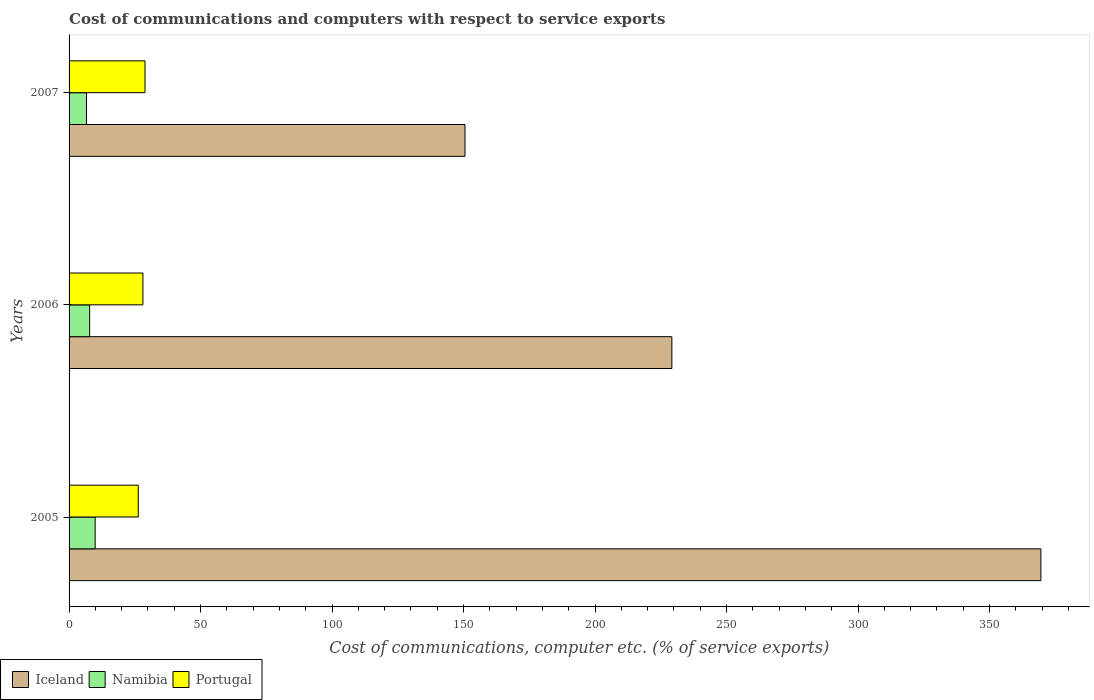How many different coloured bars are there?
Your answer should be very brief. 3. Are the number of bars per tick equal to the number of legend labels?
Ensure brevity in your answer.  Yes. How many bars are there on the 2nd tick from the bottom?
Ensure brevity in your answer.  3. In how many cases, is the number of bars for a given year not equal to the number of legend labels?
Provide a succinct answer. 0. What is the cost of communications and computers in Namibia in 2005?
Give a very brief answer. 9.92. Across all years, what is the maximum cost of communications and computers in Portugal?
Give a very brief answer. 28.88. Across all years, what is the minimum cost of communications and computers in Namibia?
Provide a short and direct response. 6.63. In which year was the cost of communications and computers in Iceland minimum?
Your answer should be very brief. 2007. What is the total cost of communications and computers in Namibia in the graph?
Provide a succinct answer. 24.37. What is the difference between the cost of communications and computers in Iceland in 2006 and that in 2007?
Offer a very short reply. 78.66. What is the difference between the cost of communications and computers in Namibia in 2005 and the cost of communications and computers in Portugal in 2007?
Ensure brevity in your answer.  -18.95. What is the average cost of communications and computers in Portugal per year?
Offer a terse response. 27.76. In the year 2005, what is the difference between the cost of communications and computers in Namibia and cost of communications and computers in Iceland?
Ensure brevity in your answer.  -359.62. In how many years, is the cost of communications and computers in Portugal greater than 300 %?
Give a very brief answer. 0. What is the ratio of the cost of communications and computers in Portugal in 2005 to that in 2007?
Offer a very short reply. 0.91. Is the difference between the cost of communications and computers in Namibia in 2005 and 2006 greater than the difference between the cost of communications and computers in Iceland in 2005 and 2006?
Give a very brief answer. No. What is the difference between the highest and the second highest cost of communications and computers in Iceland?
Make the answer very short. 140.33. What is the difference between the highest and the lowest cost of communications and computers in Portugal?
Your answer should be very brief. 2.57. Is the sum of the cost of communications and computers in Portugal in 2005 and 2007 greater than the maximum cost of communications and computers in Namibia across all years?
Your answer should be very brief. Yes. What does the 3rd bar from the top in 2007 represents?
Keep it short and to the point. Iceland. What does the 2nd bar from the bottom in 2006 represents?
Provide a succinct answer. Namibia. Is it the case that in every year, the sum of the cost of communications and computers in Iceland and cost of communications and computers in Namibia is greater than the cost of communications and computers in Portugal?
Offer a terse response. Yes. How many bars are there?
Your answer should be very brief. 9. Are all the bars in the graph horizontal?
Keep it short and to the point. Yes. Are the values on the major ticks of X-axis written in scientific E-notation?
Make the answer very short. No. Does the graph contain any zero values?
Provide a short and direct response. No. Does the graph contain grids?
Keep it short and to the point. No. How are the legend labels stacked?
Provide a succinct answer. Horizontal. What is the title of the graph?
Your answer should be very brief. Cost of communications and computers with respect to service exports. What is the label or title of the X-axis?
Provide a succinct answer. Cost of communications, computer etc. (% of service exports). What is the Cost of communications, computer etc. (% of service exports) in Iceland in 2005?
Give a very brief answer. 369.54. What is the Cost of communications, computer etc. (% of service exports) of Namibia in 2005?
Keep it short and to the point. 9.92. What is the Cost of communications, computer etc. (% of service exports) of Portugal in 2005?
Your answer should be very brief. 26.31. What is the Cost of communications, computer etc. (% of service exports) of Iceland in 2006?
Your answer should be very brief. 229.21. What is the Cost of communications, computer etc. (% of service exports) in Namibia in 2006?
Keep it short and to the point. 7.82. What is the Cost of communications, computer etc. (% of service exports) in Portugal in 2006?
Provide a succinct answer. 28.08. What is the Cost of communications, computer etc. (% of service exports) in Iceland in 2007?
Keep it short and to the point. 150.55. What is the Cost of communications, computer etc. (% of service exports) in Namibia in 2007?
Give a very brief answer. 6.63. What is the Cost of communications, computer etc. (% of service exports) of Portugal in 2007?
Provide a succinct answer. 28.88. Across all years, what is the maximum Cost of communications, computer etc. (% of service exports) of Iceland?
Give a very brief answer. 369.54. Across all years, what is the maximum Cost of communications, computer etc. (% of service exports) in Namibia?
Offer a terse response. 9.92. Across all years, what is the maximum Cost of communications, computer etc. (% of service exports) of Portugal?
Your answer should be very brief. 28.88. Across all years, what is the minimum Cost of communications, computer etc. (% of service exports) of Iceland?
Ensure brevity in your answer.  150.55. Across all years, what is the minimum Cost of communications, computer etc. (% of service exports) of Namibia?
Provide a succinct answer. 6.63. Across all years, what is the minimum Cost of communications, computer etc. (% of service exports) of Portugal?
Offer a terse response. 26.31. What is the total Cost of communications, computer etc. (% of service exports) of Iceland in the graph?
Provide a succinct answer. 749.31. What is the total Cost of communications, computer etc. (% of service exports) in Namibia in the graph?
Offer a very short reply. 24.37. What is the total Cost of communications, computer etc. (% of service exports) in Portugal in the graph?
Your answer should be compact. 83.27. What is the difference between the Cost of communications, computer etc. (% of service exports) in Iceland in 2005 and that in 2006?
Provide a succinct answer. 140.33. What is the difference between the Cost of communications, computer etc. (% of service exports) of Namibia in 2005 and that in 2006?
Provide a succinct answer. 2.1. What is the difference between the Cost of communications, computer etc. (% of service exports) in Portugal in 2005 and that in 2006?
Keep it short and to the point. -1.77. What is the difference between the Cost of communications, computer etc. (% of service exports) in Iceland in 2005 and that in 2007?
Keep it short and to the point. 218.99. What is the difference between the Cost of communications, computer etc. (% of service exports) of Namibia in 2005 and that in 2007?
Your answer should be very brief. 3.29. What is the difference between the Cost of communications, computer etc. (% of service exports) in Portugal in 2005 and that in 2007?
Make the answer very short. -2.57. What is the difference between the Cost of communications, computer etc. (% of service exports) of Iceland in 2006 and that in 2007?
Your answer should be compact. 78.66. What is the difference between the Cost of communications, computer etc. (% of service exports) in Namibia in 2006 and that in 2007?
Offer a very short reply. 1.19. What is the difference between the Cost of communications, computer etc. (% of service exports) of Portugal in 2006 and that in 2007?
Give a very brief answer. -0.8. What is the difference between the Cost of communications, computer etc. (% of service exports) of Iceland in 2005 and the Cost of communications, computer etc. (% of service exports) of Namibia in 2006?
Your response must be concise. 361.72. What is the difference between the Cost of communications, computer etc. (% of service exports) in Iceland in 2005 and the Cost of communications, computer etc. (% of service exports) in Portugal in 2006?
Provide a short and direct response. 341.46. What is the difference between the Cost of communications, computer etc. (% of service exports) of Namibia in 2005 and the Cost of communications, computer etc. (% of service exports) of Portugal in 2006?
Ensure brevity in your answer.  -18.16. What is the difference between the Cost of communications, computer etc. (% of service exports) in Iceland in 2005 and the Cost of communications, computer etc. (% of service exports) in Namibia in 2007?
Your answer should be very brief. 362.91. What is the difference between the Cost of communications, computer etc. (% of service exports) of Iceland in 2005 and the Cost of communications, computer etc. (% of service exports) of Portugal in 2007?
Your response must be concise. 340.67. What is the difference between the Cost of communications, computer etc. (% of service exports) of Namibia in 2005 and the Cost of communications, computer etc. (% of service exports) of Portugal in 2007?
Provide a succinct answer. -18.95. What is the difference between the Cost of communications, computer etc. (% of service exports) of Iceland in 2006 and the Cost of communications, computer etc. (% of service exports) of Namibia in 2007?
Make the answer very short. 222.58. What is the difference between the Cost of communications, computer etc. (% of service exports) in Iceland in 2006 and the Cost of communications, computer etc. (% of service exports) in Portugal in 2007?
Offer a terse response. 200.34. What is the difference between the Cost of communications, computer etc. (% of service exports) in Namibia in 2006 and the Cost of communications, computer etc. (% of service exports) in Portugal in 2007?
Your answer should be compact. -21.05. What is the average Cost of communications, computer etc. (% of service exports) in Iceland per year?
Ensure brevity in your answer.  249.77. What is the average Cost of communications, computer etc. (% of service exports) of Namibia per year?
Your answer should be very brief. 8.12. What is the average Cost of communications, computer etc. (% of service exports) in Portugal per year?
Offer a terse response. 27.75. In the year 2005, what is the difference between the Cost of communications, computer etc. (% of service exports) of Iceland and Cost of communications, computer etc. (% of service exports) of Namibia?
Provide a succinct answer. 359.62. In the year 2005, what is the difference between the Cost of communications, computer etc. (% of service exports) in Iceland and Cost of communications, computer etc. (% of service exports) in Portugal?
Your response must be concise. 343.23. In the year 2005, what is the difference between the Cost of communications, computer etc. (% of service exports) of Namibia and Cost of communications, computer etc. (% of service exports) of Portugal?
Your response must be concise. -16.39. In the year 2006, what is the difference between the Cost of communications, computer etc. (% of service exports) of Iceland and Cost of communications, computer etc. (% of service exports) of Namibia?
Provide a short and direct response. 221.39. In the year 2006, what is the difference between the Cost of communications, computer etc. (% of service exports) of Iceland and Cost of communications, computer etc. (% of service exports) of Portugal?
Provide a succinct answer. 201.13. In the year 2006, what is the difference between the Cost of communications, computer etc. (% of service exports) in Namibia and Cost of communications, computer etc. (% of service exports) in Portugal?
Keep it short and to the point. -20.26. In the year 2007, what is the difference between the Cost of communications, computer etc. (% of service exports) in Iceland and Cost of communications, computer etc. (% of service exports) in Namibia?
Offer a terse response. 143.92. In the year 2007, what is the difference between the Cost of communications, computer etc. (% of service exports) in Iceland and Cost of communications, computer etc. (% of service exports) in Portugal?
Keep it short and to the point. 121.68. In the year 2007, what is the difference between the Cost of communications, computer etc. (% of service exports) of Namibia and Cost of communications, computer etc. (% of service exports) of Portugal?
Offer a very short reply. -22.25. What is the ratio of the Cost of communications, computer etc. (% of service exports) in Iceland in 2005 to that in 2006?
Offer a terse response. 1.61. What is the ratio of the Cost of communications, computer etc. (% of service exports) of Namibia in 2005 to that in 2006?
Make the answer very short. 1.27. What is the ratio of the Cost of communications, computer etc. (% of service exports) of Portugal in 2005 to that in 2006?
Give a very brief answer. 0.94. What is the ratio of the Cost of communications, computer etc. (% of service exports) of Iceland in 2005 to that in 2007?
Provide a short and direct response. 2.45. What is the ratio of the Cost of communications, computer etc. (% of service exports) of Namibia in 2005 to that in 2007?
Give a very brief answer. 1.5. What is the ratio of the Cost of communications, computer etc. (% of service exports) in Portugal in 2005 to that in 2007?
Offer a very short reply. 0.91. What is the ratio of the Cost of communications, computer etc. (% of service exports) of Iceland in 2006 to that in 2007?
Provide a succinct answer. 1.52. What is the ratio of the Cost of communications, computer etc. (% of service exports) in Namibia in 2006 to that in 2007?
Ensure brevity in your answer.  1.18. What is the ratio of the Cost of communications, computer etc. (% of service exports) in Portugal in 2006 to that in 2007?
Your answer should be very brief. 0.97. What is the difference between the highest and the second highest Cost of communications, computer etc. (% of service exports) of Iceland?
Provide a succinct answer. 140.33. What is the difference between the highest and the second highest Cost of communications, computer etc. (% of service exports) in Namibia?
Provide a short and direct response. 2.1. What is the difference between the highest and the second highest Cost of communications, computer etc. (% of service exports) of Portugal?
Provide a short and direct response. 0.8. What is the difference between the highest and the lowest Cost of communications, computer etc. (% of service exports) in Iceland?
Keep it short and to the point. 218.99. What is the difference between the highest and the lowest Cost of communications, computer etc. (% of service exports) in Namibia?
Your response must be concise. 3.29. What is the difference between the highest and the lowest Cost of communications, computer etc. (% of service exports) of Portugal?
Your answer should be very brief. 2.57. 